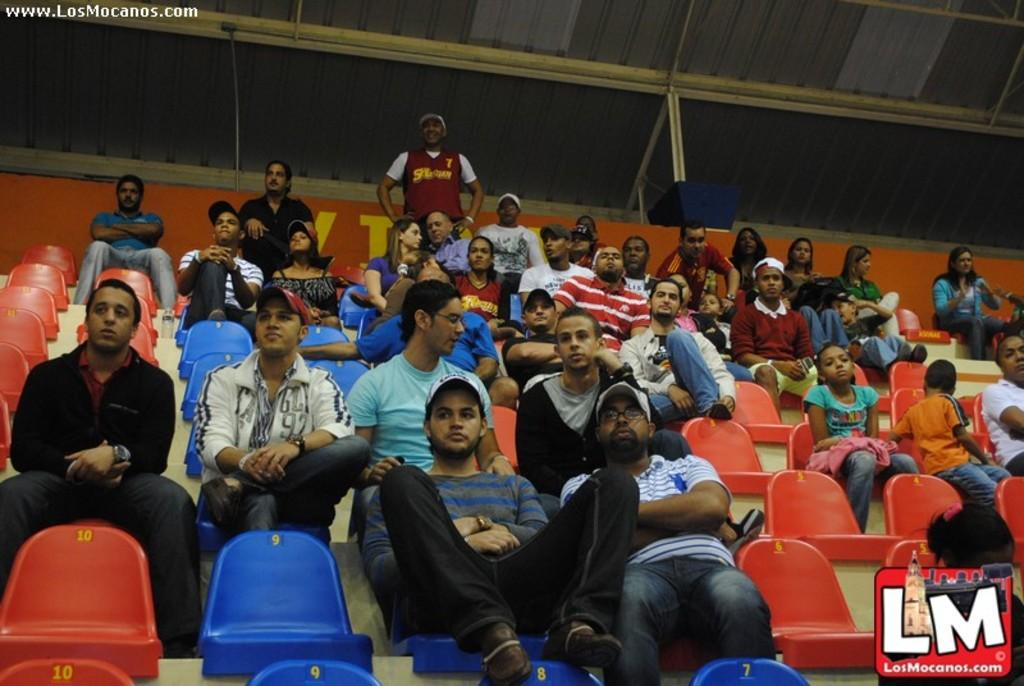What can be seen in the background of the image? There are people in the stands in the image. What else is present on the image besides the people in the stands? There is some text and a logo symbol on the image. What type of hair can be seen on the people in the stands in the image? There is no specific information about the hair of the people in the stands in the image, so it cannot be determined from the image. 